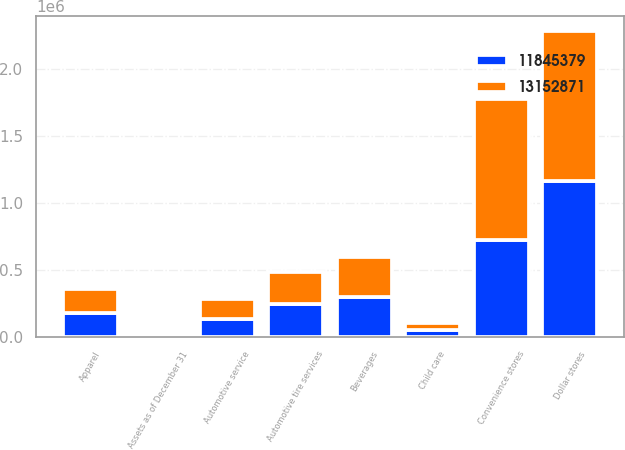Convert chart. <chart><loc_0><loc_0><loc_500><loc_500><stacked_bar_chart><ecel><fcel>Assets as of December 31<fcel>Apparel<fcel>Automotive service<fcel>Automotive tire services<fcel>Beverages<fcel>Child care<fcel>Convenience stores<fcel>Dollar stores<nl><fcel>1.31529e+07<fcel>2016<fcel>175418<fcel>152220<fcel>238151<fcel>293447<fcel>49584<fcel>1.05028e+06<fcel>1.1209e+06<nl><fcel>1.18454e+07<fcel>2015<fcel>180175<fcel>129328<fcel>247200<fcel>297724<fcel>52392<fcel>724972<fcel>1.15895e+06<nl></chart> 